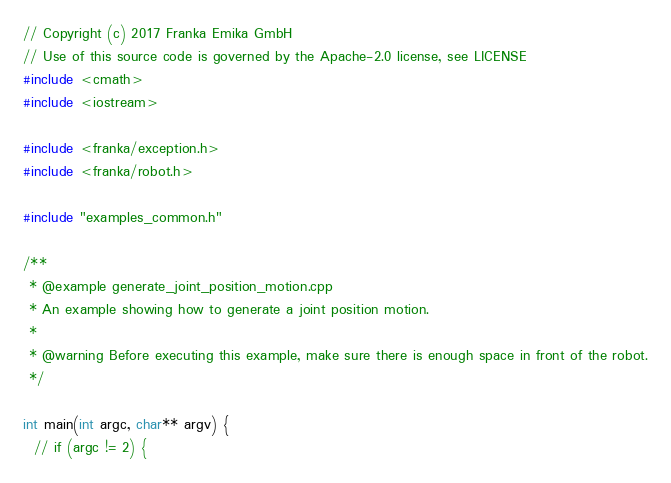Convert code to text. <code><loc_0><loc_0><loc_500><loc_500><_C++_>// Copyright (c) 2017 Franka Emika GmbH
// Use of this source code is governed by the Apache-2.0 license, see LICENSE
#include <cmath>
#include <iostream>

#include <franka/exception.h>
#include <franka/robot.h>

#include "examples_common.h"

/**
 * @example generate_joint_position_motion.cpp
 * An example showing how to generate a joint position motion.
 *
 * @warning Before executing this example, make sure there is enough space in front of the robot.
 */

int main(int argc, char** argv) {
  // if (argc != 2) {</code> 